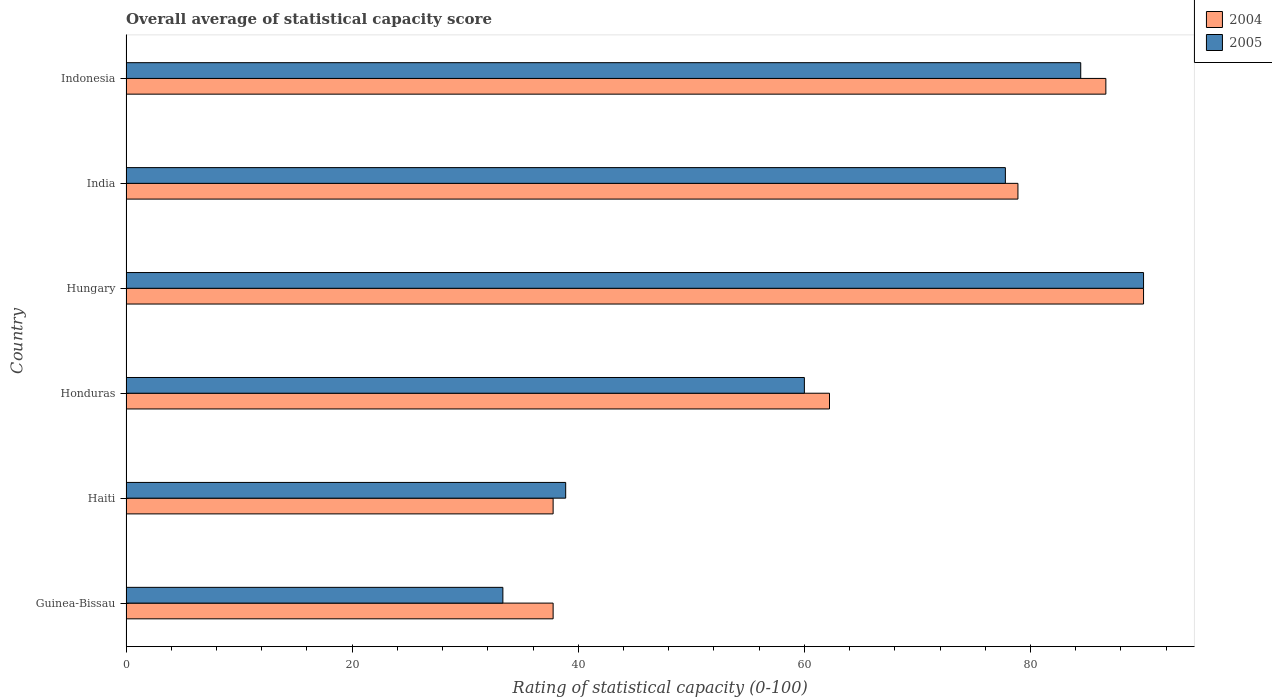How many groups of bars are there?
Offer a very short reply. 6. Are the number of bars per tick equal to the number of legend labels?
Provide a succinct answer. Yes. How many bars are there on the 3rd tick from the top?
Make the answer very short. 2. How many bars are there on the 1st tick from the bottom?
Give a very brief answer. 2. What is the rating of statistical capacity in 2004 in Haiti?
Offer a very short reply. 37.78. Across all countries, what is the maximum rating of statistical capacity in 2005?
Your answer should be very brief. 90. Across all countries, what is the minimum rating of statistical capacity in 2004?
Provide a short and direct response. 37.78. In which country was the rating of statistical capacity in 2005 maximum?
Give a very brief answer. Hungary. In which country was the rating of statistical capacity in 2004 minimum?
Keep it short and to the point. Guinea-Bissau. What is the total rating of statistical capacity in 2005 in the graph?
Your answer should be very brief. 384.44. What is the difference between the rating of statistical capacity in 2004 in Haiti and that in Indonesia?
Provide a succinct answer. -48.89. What is the difference between the rating of statistical capacity in 2004 in India and the rating of statistical capacity in 2005 in Guinea-Bissau?
Offer a terse response. 45.56. What is the average rating of statistical capacity in 2004 per country?
Ensure brevity in your answer.  65.56. What is the difference between the rating of statistical capacity in 2005 and rating of statistical capacity in 2004 in Haiti?
Make the answer very short. 1.11. What is the ratio of the rating of statistical capacity in 2004 in Haiti to that in Hungary?
Your answer should be very brief. 0.42. Is the rating of statistical capacity in 2005 in Guinea-Bissau less than that in Hungary?
Your response must be concise. Yes. What is the difference between the highest and the second highest rating of statistical capacity in 2005?
Ensure brevity in your answer.  5.56. What is the difference between the highest and the lowest rating of statistical capacity in 2004?
Your answer should be compact. 52.22. What does the 2nd bar from the bottom in Indonesia represents?
Provide a short and direct response. 2005. How many bars are there?
Your response must be concise. 12. Does the graph contain any zero values?
Ensure brevity in your answer.  No. How many legend labels are there?
Your answer should be very brief. 2. How are the legend labels stacked?
Provide a short and direct response. Vertical. What is the title of the graph?
Make the answer very short. Overall average of statistical capacity score. Does "1963" appear as one of the legend labels in the graph?
Ensure brevity in your answer.  No. What is the label or title of the X-axis?
Your answer should be compact. Rating of statistical capacity (0-100). What is the Rating of statistical capacity (0-100) in 2004 in Guinea-Bissau?
Provide a succinct answer. 37.78. What is the Rating of statistical capacity (0-100) in 2005 in Guinea-Bissau?
Offer a terse response. 33.33. What is the Rating of statistical capacity (0-100) in 2004 in Haiti?
Provide a short and direct response. 37.78. What is the Rating of statistical capacity (0-100) in 2005 in Haiti?
Your answer should be very brief. 38.89. What is the Rating of statistical capacity (0-100) of 2004 in Honduras?
Your response must be concise. 62.22. What is the Rating of statistical capacity (0-100) of 2005 in Hungary?
Your answer should be very brief. 90. What is the Rating of statistical capacity (0-100) of 2004 in India?
Provide a succinct answer. 78.89. What is the Rating of statistical capacity (0-100) in 2005 in India?
Offer a very short reply. 77.78. What is the Rating of statistical capacity (0-100) in 2004 in Indonesia?
Provide a succinct answer. 86.67. What is the Rating of statistical capacity (0-100) in 2005 in Indonesia?
Ensure brevity in your answer.  84.44. Across all countries, what is the minimum Rating of statistical capacity (0-100) in 2004?
Provide a succinct answer. 37.78. Across all countries, what is the minimum Rating of statistical capacity (0-100) of 2005?
Ensure brevity in your answer.  33.33. What is the total Rating of statistical capacity (0-100) of 2004 in the graph?
Offer a very short reply. 393.33. What is the total Rating of statistical capacity (0-100) in 2005 in the graph?
Offer a terse response. 384.44. What is the difference between the Rating of statistical capacity (0-100) of 2005 in Guinea-Bissau and that in Haiti?
Provide a short and direct response. -5.56. What is the difference between the Rating of statistical capacity (0-100) of 2004 in Guinea-Bissau and that in Honduras?
Offer a very short reply. -24.44. What is the difference between the Rating of statistical capacity (0-100) of 2005 in Guinea-Bissau and that in Honduras?
Provide a succinct answer. -26.67. What is the difference between the Rating of statistical capacity (0-100) of 2004 in Guinea-Bissau and that in Hungary?
Your answer should be very brief. -52.22. What is the difference between the Rating of statistical capacity (0-100) in 2005 in Guinea-Bissau and that in Hungary?
Your answer should be very brief. -56.67. What is the difference between the Rating of statistical capacity (0-100) of 2004 in Guinea-Bissau and that in India?
Keep it short and to the point. -41.11. What is the difference between the Rating of statistical capacity (0-100) of 2005 in Guinea-Bissau and that in India?
Make the answer very short. -44.44. What is the difference between the Rating of statistical capacity (0-100) of 2004 in Guinea-Bissau and that in Indonesia?
Give a very brief answer. -48.89. What is the difference between the Rating of statistical capacity (0-100) in 2005 in Guinea-Bissau and that in Indonesia?
Keep it short and to the point. -51.11. What is the difference between the Rating of statistical capacity (0-100) in 2004 in Haiti and that in Honduras?
Provide a short and direct response. -24.44. What is the difference between the Rating of statistical capacity (0-100) of 2005 in Haiti and that in Honduras?
Your response must be concise. -21.11. What is the difference between the Rating of statistical capacity (0-100) of 2004 in Haiti and that in Hungary?
Your answer should be compact. -52.22. What is the difference between the Rating of statistical capacity (0-100) in 2005 in Haiti and that in Hungary?
Make the answer very short. -51.11. What is the difference between the Rating of statistical capacity (0-100) in 2004 in Haiti and that in India?
Keep it short and to the point. -41.11. What is the difference between the Rating of statistical capacity (0-100) of 2005 in Haiti and that in India?
Provide a succinct answer. -38.89. What is the difference between the Rating of statistical capacity (0-100) of 2004 in Haiti and that in Indonesia?
Give a very brief answer. -48.89. What is the difference between the Rating of statistical capacity (0-100) of 2005 in Haiti and that in Indonesia?
Your answer should be compact. -45.56. What is the difference between the Rating of statistical capacity (0-100) in 2004 in Honduras and that in Hungary?
Your answer should be very brief. -27.78. What is the difference between the Rating of statistical capacity (0-100) of 2005 in Honduras and that in Hungary?
Provide a succinct answer. -30. What is the difference between the Rating of statistical capacity (0-100) in 2004 in Honduras and that in India?
Provide a succinct answer. -16.67. What is the difference between the Rating of statistical capacity (0-100) of 2005 in Honduras and that in India?
Ensure brevity in your answer.  -17.78. What is the difference between the Rating of statistical capacity (0-100) of 2004 in Honduras and that in Indonesia?
Provide a succinct answer. -24.44. What is the difference between the Rating of statistical capacity (0-100) of 2005 in Honduras and that in Indonesia?
Make the answer very short. -24.44. What is the difference between the Rating of statistical capacity (0-100) of 2004 in Hungary and that in India?
Keep it short and to the point. 11.11. What is the difference between the Rating of statistical capacity (0-100) of 2005 in Hungary and that in India?
Give a very brief answer. 12.22. What is the difference between the Rating of statistical capacity (0-100) of 2004 in Hungary and that in Indonesia?
Ensure brevity in your answer.  3.33. What is the difference between the Rating of statistical capacity (0-100) in 2005 in Hungary and that in Indonesia?
Your answer should be very brief. 5.56. What is the difference between the Rating of statistical capacity (0-100) in 2004 in India and that in Indonesia?
Your answer should be compact. -7.78. What is the difference between the Rating of statistical capacity (0-100) of 2005 in India and that in Indonesia?
Your answer should be compact. -6.67. What is the difference between the Rating of statistical capacity (0-100) in 2004 in Guinea-Bissau and the Rating of statistical capacity (0-100) in 2005 in Haiti?
Your answer should be very brief. -1.11. What is the difference between the Rating of statistical capacity (0-100) of 2004 in Guinea-Bissau and the Rating of statistical capacity (0-100) of 2005 in Honduras?
Provide a succinct answer. -22.22. What is the difference between the Rating of statistical capacity (0-100) of 2004 in Guinea-Bissau and the Rating of statistical capacity (0-100) of 2005 in Hungary?
Provide a short and direct response. -52.22. What is the difference between the Rating of statistical capacity (0-100) in 2004 in Guinea-Bissau and the Rating of statistical capacity (0-100) in 2005 in India?
Your answer should be very brief. -40. What is the difference between the Rating of statistical capacity (0-100) in 2004 in Guinea-Bissau and the Rating of statistical capacity (0-100) in 2005 in Indonesia?
Make the answer very short. -46.67. What is the difference between the Rating of statistical capacity (0-100) of 2004 in Haiti and the Rating of statistical capacity (0-100) of 2005 in Honduras?
Give a very brief answer. -22.22. What is the difference between the Rating of statistical capacity (0-100) in 2004 in Haiti and the Rating of statistical capacity (0-100) in 2005 in Hungary?
Ensure brevity in your answer.  -52.22. What is the difference between the Rating of statistical capacity (0-100) in 2004 in Haiti and the Rating of statistical capacity (0-100) in 2005 in Indonesia?
Your answer should be compact. -46.67. What is the difference between the Rating of statistical capacity (0-100) in 2004 in Honduras and the Rating of statistical capacity (0-100) in 2005 in Hungary?
Keep it short and to the point. -27.78. What is the difference between the Rating of statistical capacity (0-100) of 2004 in Honduras and the Rating of statistical capacity (0-100) of 2005 in India?
Give a very brief answer. -15.56. What is the difference between the Rating of statistical capacity (0-100) of 2004 in Honduras and the Rating of statistical capacity (0-100) of 2005 in Indonesia?
Your answer should be compact. -22.22. What is the difference between the Rating of statistical capacity (0-100) in 2004 in Hungary and the Rating of statistical capacity (0-100) in 2005 in India?
Provide a succinct answer. 12.22. What is the difference between the Rating of statistical capacity (0-100) in 2004 in Hungary and the Rating of statistical capacity (0-100) in 2005 in Indonesia?
Ensure brevity in your answer.  5.56. What is the difference between the Rating of statistical capacity (0-100) of 2004 in India and the Rating of statistical capacity (0-100) of 2005 in Indonesia?
Make the answer very short. -5.56. What is the average Rating of statistical capacity (0-100) in 2004 per country?
Offer a very short reply. 65.56. What is the average Rating of statistical capacity (0-100) in 2005 per country?
Your answer should be very brief. 64.07. What is the difference between the Rating of statistical capacity (0-100) of 2004 and Rating of statistical capacity (0-100) of 2005 in Guinea-Bissau?
Your response must be concise. 4.44. What is the difference between the Rating of statistical capacity (0-100) of 2004 and Rating of statistical capacity (0-100) of 2005 in Haiti?
Your response must be concise. -1.11. What is the difference between the Rating of statistical capacity (0-100) of 2004 and Rating of statistical capacity (0-100) of 2005 in Honduras?
Provide a succinct answer. 2.22. What is the difference between the Rating of statistical capacity (0-100) in 2004 and Rating of statistical capacity (0-100) in 2005 in Hungary?
Your response must be concise. 0. What is the difference between the Rating of statistical capacity (0-100) in 2004 and Rating of statistical capacity (0-100) in 2005 in Indonesia?
Keep it short and to the point. 2.22. What is the ratio of the Rating of statistical capacity (0-100) in 2004 in Guinea-Bissau to that in Honduras?
Give a very brief answer. 0.61. What is the ratio of the Rating of statistical capacity (0-100) in 2005 in Guinea-Bissau to that in Honduras?
Offer a terse response. 0.56. What is the ratio of the Rating of statistical capacity (0-100) in 2004 in Guinea-Bissau to that in Hungary?
Your answer should be very brief. 0.42. What is the ratio of the Rating of statistical capacity (0-100) of 2005 in Guinea-Bissau to that in Hungary?
Ensure brevity in your answer.  0.37. What is the ratio of the Rating of statistical capacity (0-100) in 2004 in Guinea-Bissau to that in India?
Offer a terse response. 0.48. What is the ratio of the Rating of statistical capacity (0-100) in 2005 in Guinea-Bissau to that in India?
Provide a short and direct response. 0.43. What is the ratio of the Rating of statistical capacity (0-100) of 2004 in Guinea-Bissau to that in Indonesia?
Provide a short and direct response. 0.44. What is the ratio of the Rating of statistical capacity (0-100) in 2005 in Guinea-Bissau to that in Indonesia?
Give a very brief answer. 0.39. What is the ratio of the Rating of statistical capacity (0-100) in 2004 in Haiti to that in Honduras?
Offer a very short reply. 0.61. What is the ratio of the Rating of statistical capacity (0-100) in 2005 in Haiti to that in Honduras?
Ensure brevity in your answer.  0.65. What is the ratio of the Rating of statistical capacity (0-100) of 2004 in Haiti to that in Hungary?
Your answer should be very brief. 0.42. What is the ratio of the Rating of statistical capacity (0-100) in 2005 in Haiti to that in Hungary?
Provide a short and direct response. 0.43. What is the ratio of the Rating of statistical capacity (0-100) in 2004 in Haiti to that in India?
Ensure brevity in your answer.  0.48. What is the ratio of the Rating of statistical capacity (0-100) of 2005 in Haiti to that in India?
Provide a short and direct response. 0.5. What is the ratio of the Rating of statistical capacity (0-100) in 2004 in Haiti to that in Indonesia?
Ensure brevity in your answer.  0.44. What is the ratio of the Rating of statistical capacity (0-100) of 2005 in Haiti to that in Indonesia?
Your answer should be compact. 0.46. What is the ratio of the Rating of statistical capacity (0-100) in 2004 in Honduras to that in Hungary?
Your answer should be compact. 0.69. What is the ratio of the Rating of statistical capacity (0-100) of 2004 in Honduras to that in India?
Offer a terse response. 0.79. What is the ratio of the Rating of statistical capacity (0-100) of 2005 in Honduras to that in India?
Offer a terse response. 0.77. What is the ratio of the Rating of statistical capacity (0-100) of 2004 in Honduras to that in Indonesia?
Offer a terse response. 0.72. What is the ratio of the Rating of statistical capacity (0-100) of 2005 in Honduras to that in Indonesia?
Your response must be concise. 0.71. What is the ratio of the Rating of statistical capacity (0-100) of 2004 in Hungary to that in India?
Make the answer very short. 1.14. What is the ratio of the Rating of statistical capacity (0-100) in 2005 in Hungary to that in India?
Offer a very short reply. 1.16. What is the ratio of the Rating of statistical capacity (0-100) of 2004 in Hungary to that in Indonesia?
Keep it short and to the point. 1.04. What is the ratio of the Rating of statistical capacity (0-100) in 2005 in Hungary to that in Indonesia?
Give a very brief answer. 1.07. What is the ratio of the Rating of statistical capacity (0-100) in 2004 in India to that in Indonesia?
Your answer should be very brief. 0.91. What is the ratio of the Rating of statistical capacity (0-100) of 2005 in India to that in Indonesia?
Ensure brevity in your answer.  0.92. What is the difference between the highest and the second highest Rating of statistical capacity (0-100) of 2005?
Give a very brief answer. 5.56. What is the difference between the highest and the lowest Rating of statistical capacity (0-100) of 2004?
Your response must be concise. 52.22. What is the difference between the highest and the lowest Rating of statistical capacity (0-100) of 2005?
Offer a very short reply. 56.67. 